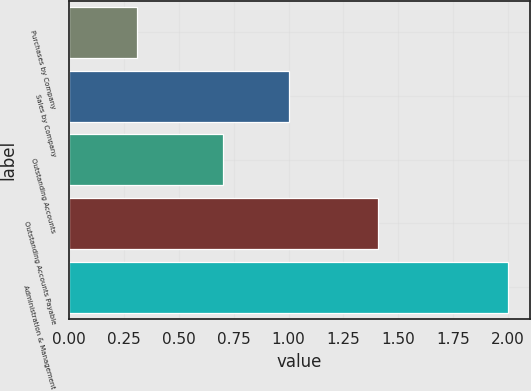Convert chart. <chart><loc_0><loc_0><loc_500><loc_500><bar_chart><fcel>Purchases by Company<fcel>Sales by Company<fcel>Outstanding Accounts<fcel>Outstanding Accounts Payable<fcel>Administration & Management<nl><fcel>0.31<fcel>1<fcel>0.7<fcel>1.41<fcel>2<nl></chart> 